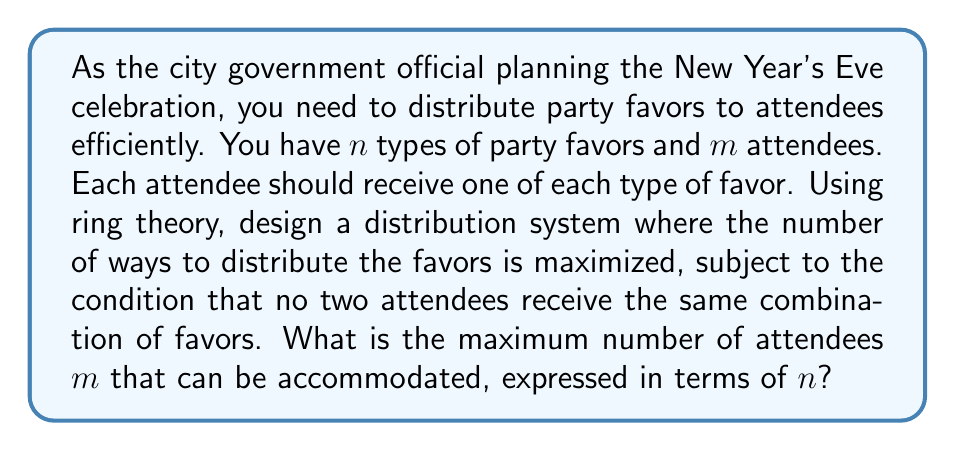Help me with this question. To solve this problem using ring theory, we can model the distribution system as follows:

1) Let $R$ be the ring of integers modulo $m$, i.e., $R = \mathbb{Z}/m\mathbb{Z}$.

2) For each type of party favor, we can assign a unique element of $R$ to each attendee. This ensures that no two attendees receive the same favor of a particular type.

3) The combination of favors an attendee receives can be represented as an $n$-tuple $(r_1, r_2, ..., r_n)$ where each $r_i \in R$.

4) To ensure no two attendees receive the same combination of favors, these $n$-tuples must be distinct for all attendees.

5) The number of distinct $n$-tuples in $R^n$ is $m^n$, as there are $m$ choices for each of the $n$ components.

6) To maximize the number of attendees, we want $m^n \geq m$, because we need at least as many distinct $n$-tuples as there are attendees.

7) The largest value of $m$ that satisfies this inequality is when $m^n = m$, or equivalently, $m^{n-1} = 1$.

8) The maximum value of $m$ that satisfies this equation is $m = 2$ when $n = 2$, and for all $n > 2$, the maximum value is $m = n$.

Therefore, the maximum number of attendees that can be accommodated is:

$$m = \begin{cases} 
2 & \text{if } n = 2 \\
n & \text{if } n > 2
\end{cases}$$

This solution utilizes the properties of modular arithmetic in the ring $\mathbb{Z}/m\mathbb{Z}$ to create a bijection between the set of attendees and the set of distinct $n$-tuples in $R^n$, thus optimizing the distribution of party favors.
Answer: The maximum number of attendees $m$ that can be accommodated, expressed in terms of $n$, is:

$$m = \max(2, n)$$

Or equivalently:

$$m = \begin{cases} 
2 & \text{if } n = 2 \\
n & \text{if } n > 2
\end{cases}$$ 